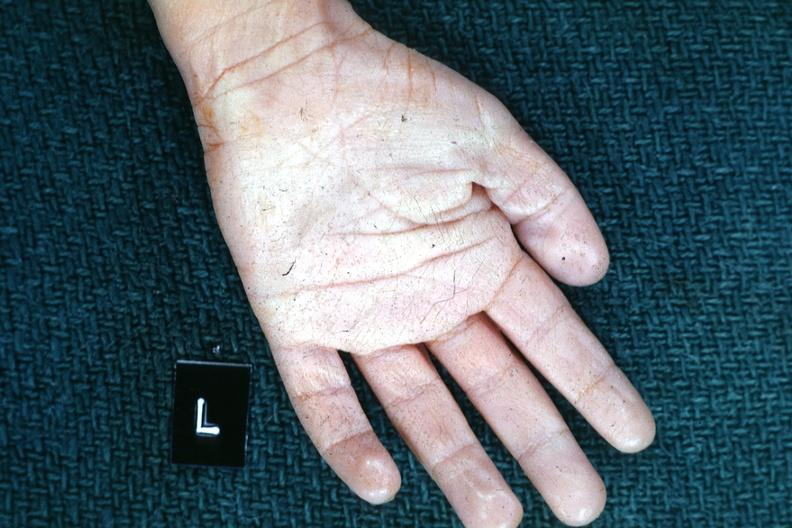what is present?
Answer the question using a single word or phrase. Normal palmar creases 